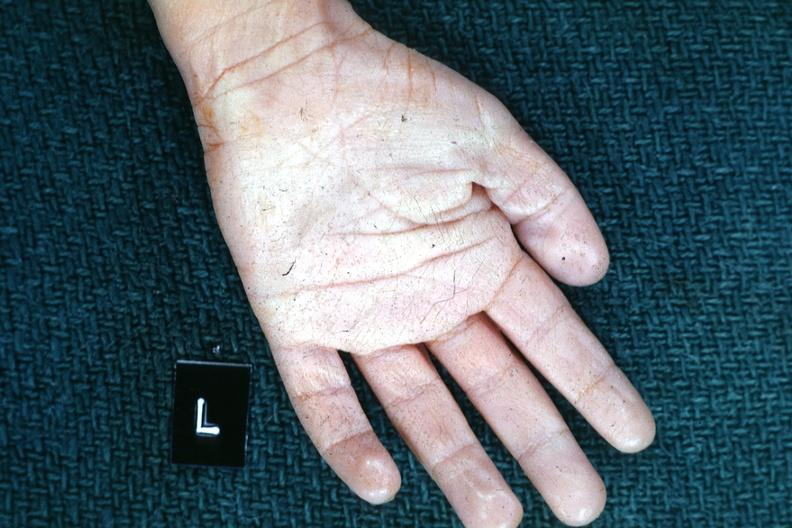what is present?
Answer the question using a single word or phrase. Normal palmar creases 